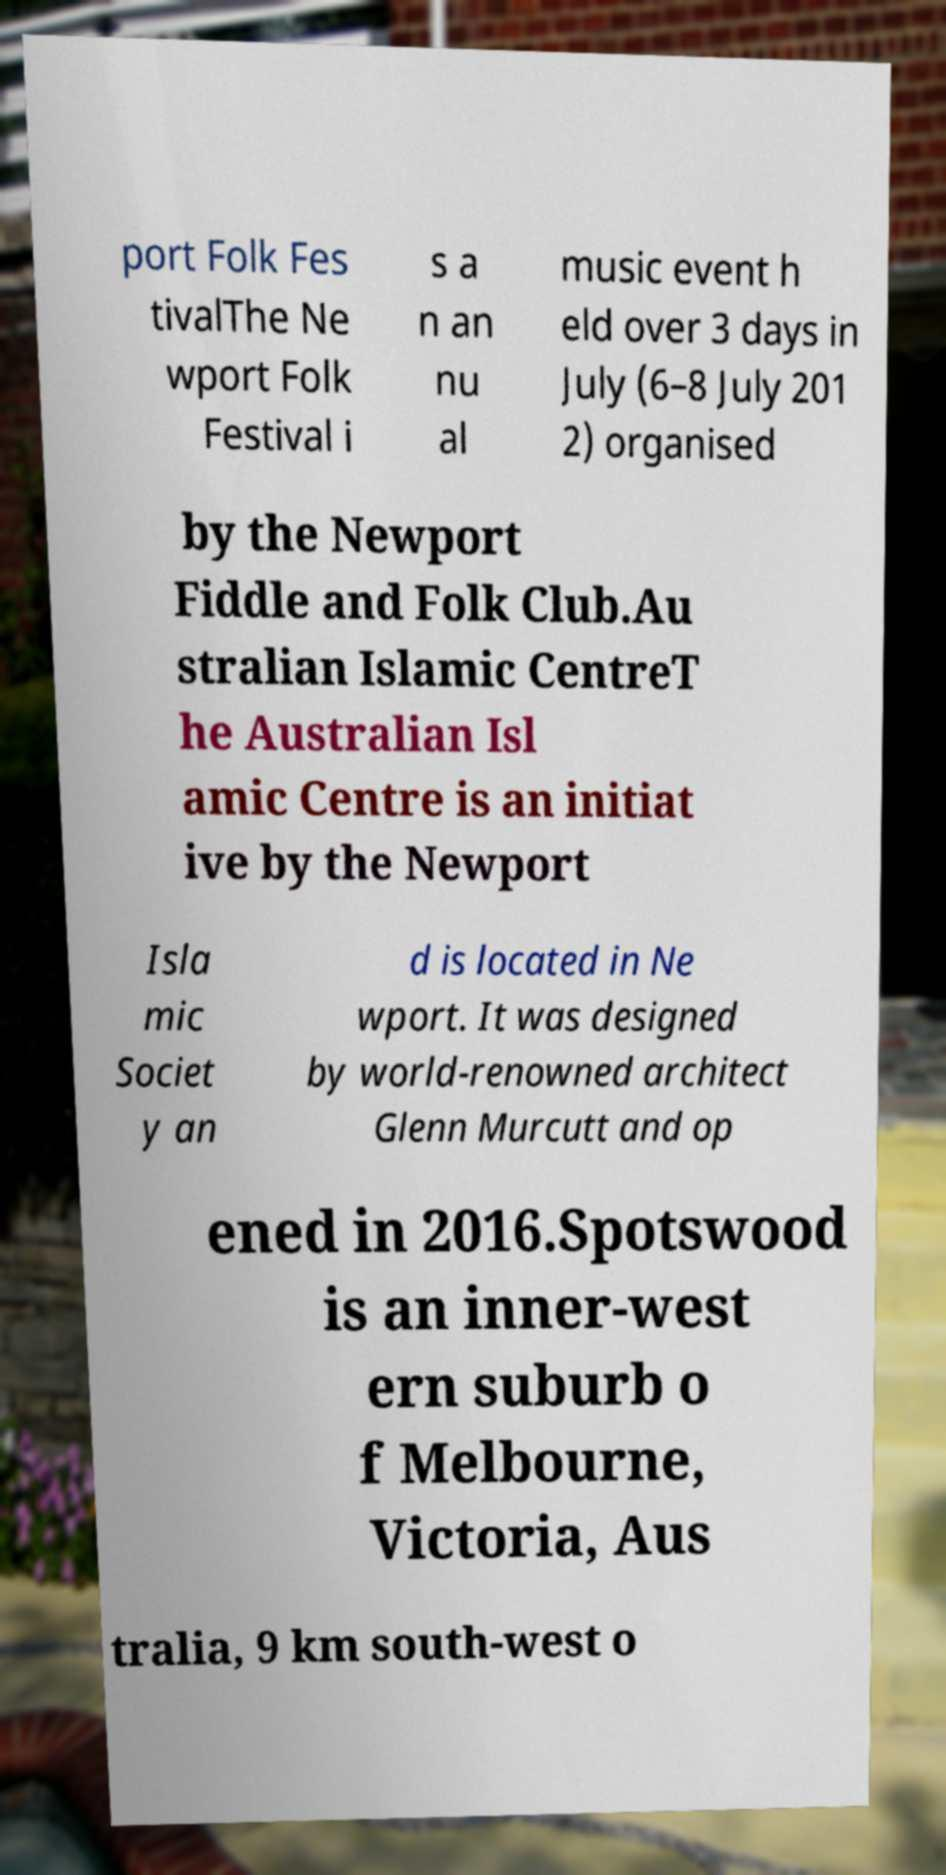There's text embedded in this image that I need extracted. Can you transcribe it verbatim? port Folk Fes tivalThe Ne wport Folk Festival i s a n an nu al music event h eld over 3 days in July (6–8 July 201 2) organised by the Newport Fiddle and Folk Club.Au stralian Islamic CentreT he Australian Isl amic Centre is an initiat ive by the Newport Isla mic Societ y an d is located in Ne wport. It was designed by world-renowned architect Glenn Murcutt and op ened in 2016.Spotswood is an inner-west ern suburb o f Melbourne, Victoria, Aus tralia, 9 km south-west o 